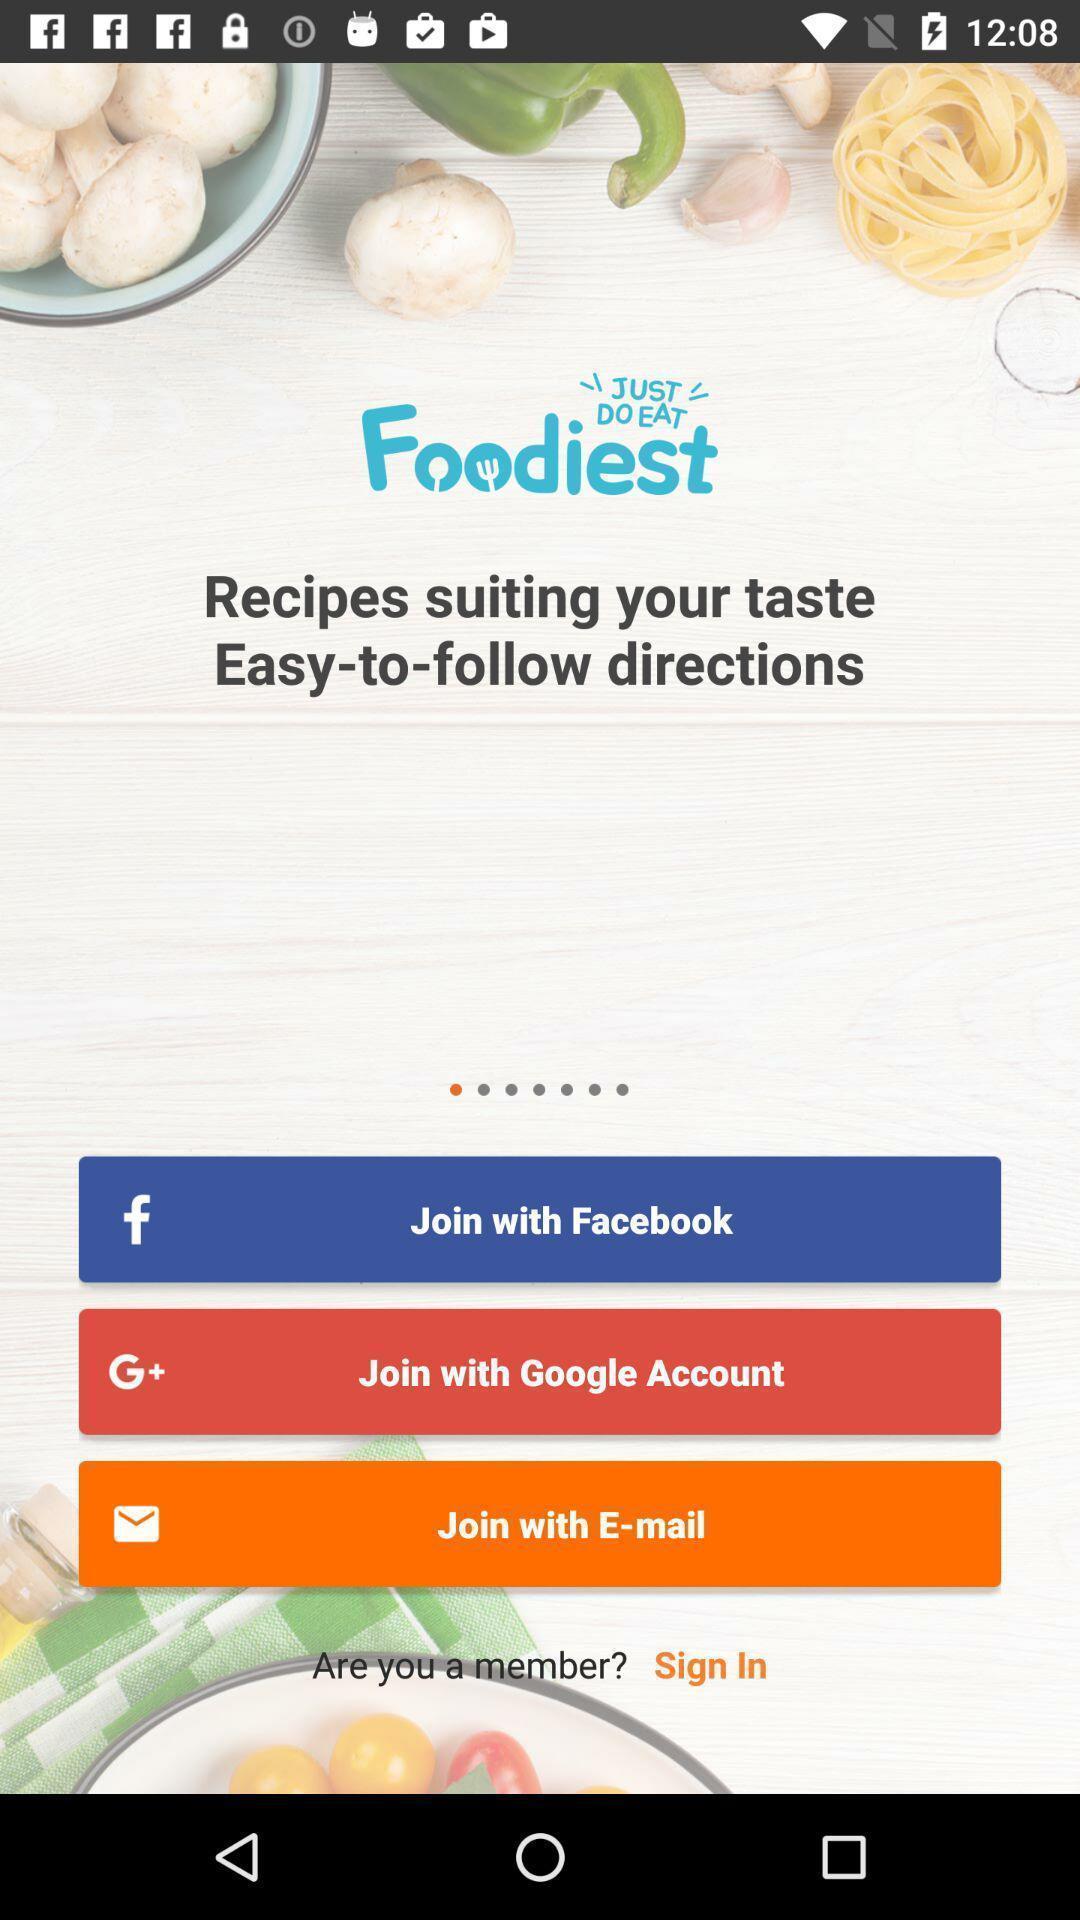Describe the visual elements of this screenshot. Sign up/in page in an recipe book app. 